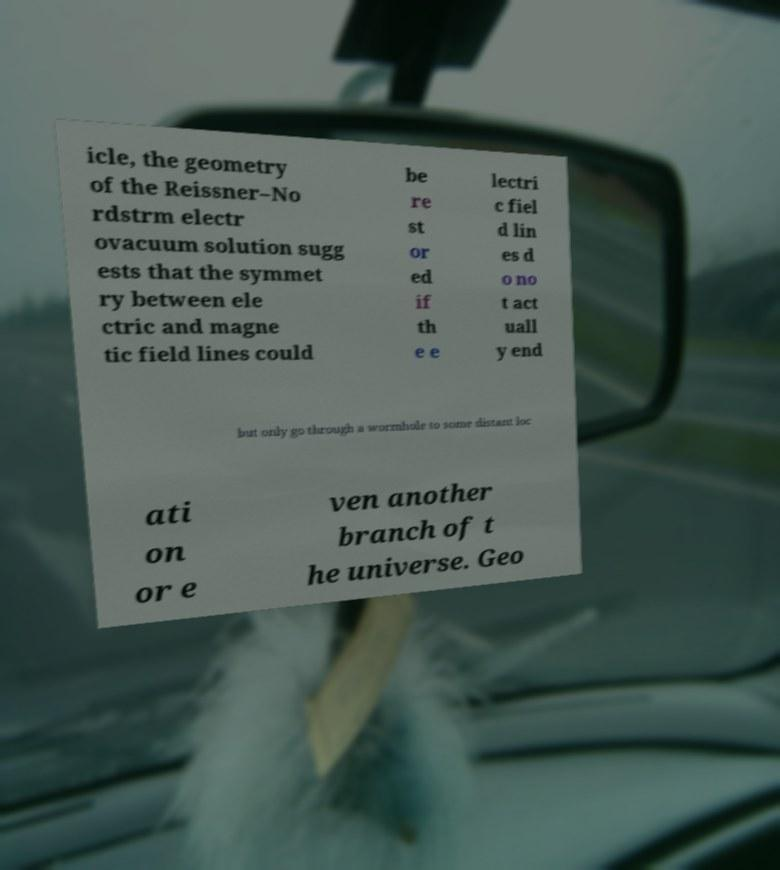There's text embedded in this image that I need extracted. Can you transcribe it verbatim? icle, the geometry of the Reissner–No rdstrm electr ovacuum solution sugg ests that the symmet ry between ele ctric and magne tic field lines could be re st or ed if th e e lectri c fiel d lin es d o no t act uall y end but only go through a wormhole to some distant loc ati on or e ven another branch of t he universe. Geo 